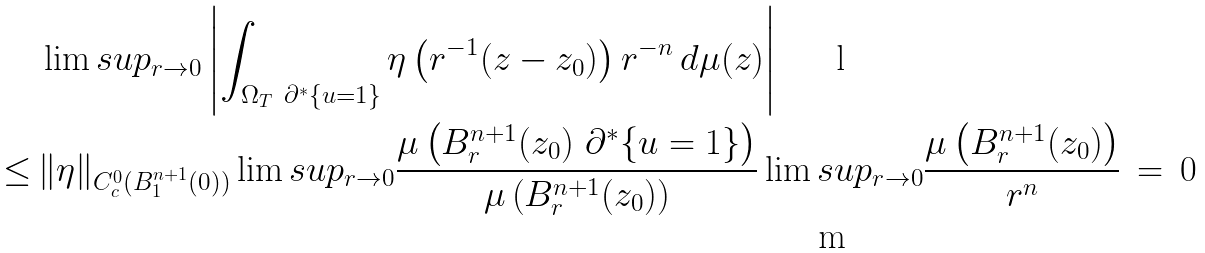<formula> <loc_0><loc_0><loc_500><loc_500>& \lim s u p _ { r \to 0 } \left | \int _ { \Omega _ { T } \ \partial ^ { * } \{ u = 1 \} } \eta \left ( r ^ { - 1 } ( z - z _ { 0 } ) \right ) r ^ { - n } \, d \mu ( z ) \right | \\ \leq \, & \| \eta \| _ { C ^ { 0 } _ { c } ( B _ { 1 } ^ { n + 1 } ( 0 ) ) } \lim s u p _ { r \to 0 } \frac { \mu \left ( B _ { r } ^ { n + 1 } ( z _ { 0 } ) \ \partial ^ { * } \{ u = 1 \} \right ) } { \mu \left ( B _ { r } ^ { n + 1 } ( z _ { 0 } ) \right ) } \lim s u p _ { r \to 0 } \frac { \mu \left ( B _ { r } ^ { n + 1 } ( z _ { 0 } ) \right ) } { r ^ { n } } \, = \, 0</formula> 